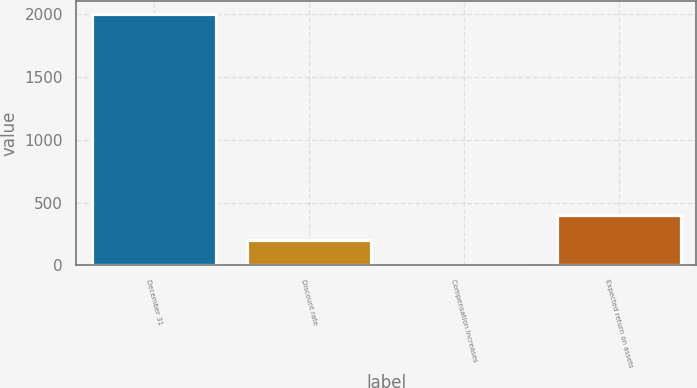Convert chart. <chart><loc_0><loc_0><loc_500><loc_500><bar_chart><fcel>December 31<fcel>Discount rate<fcel>Compensation increases<fcel>Expected return on assets<nl><fcel>2006<fcel>204.43<fcel>4.26<fcel>404.6<nl></chart> 